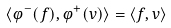<formula> <loc_0><loc_0><loc_500><loc_500>\langle \varphi ^ { - } ( f ) , \varphi ^ { + } ( v ) \rangle = \langle f , v \rangle</formula> 